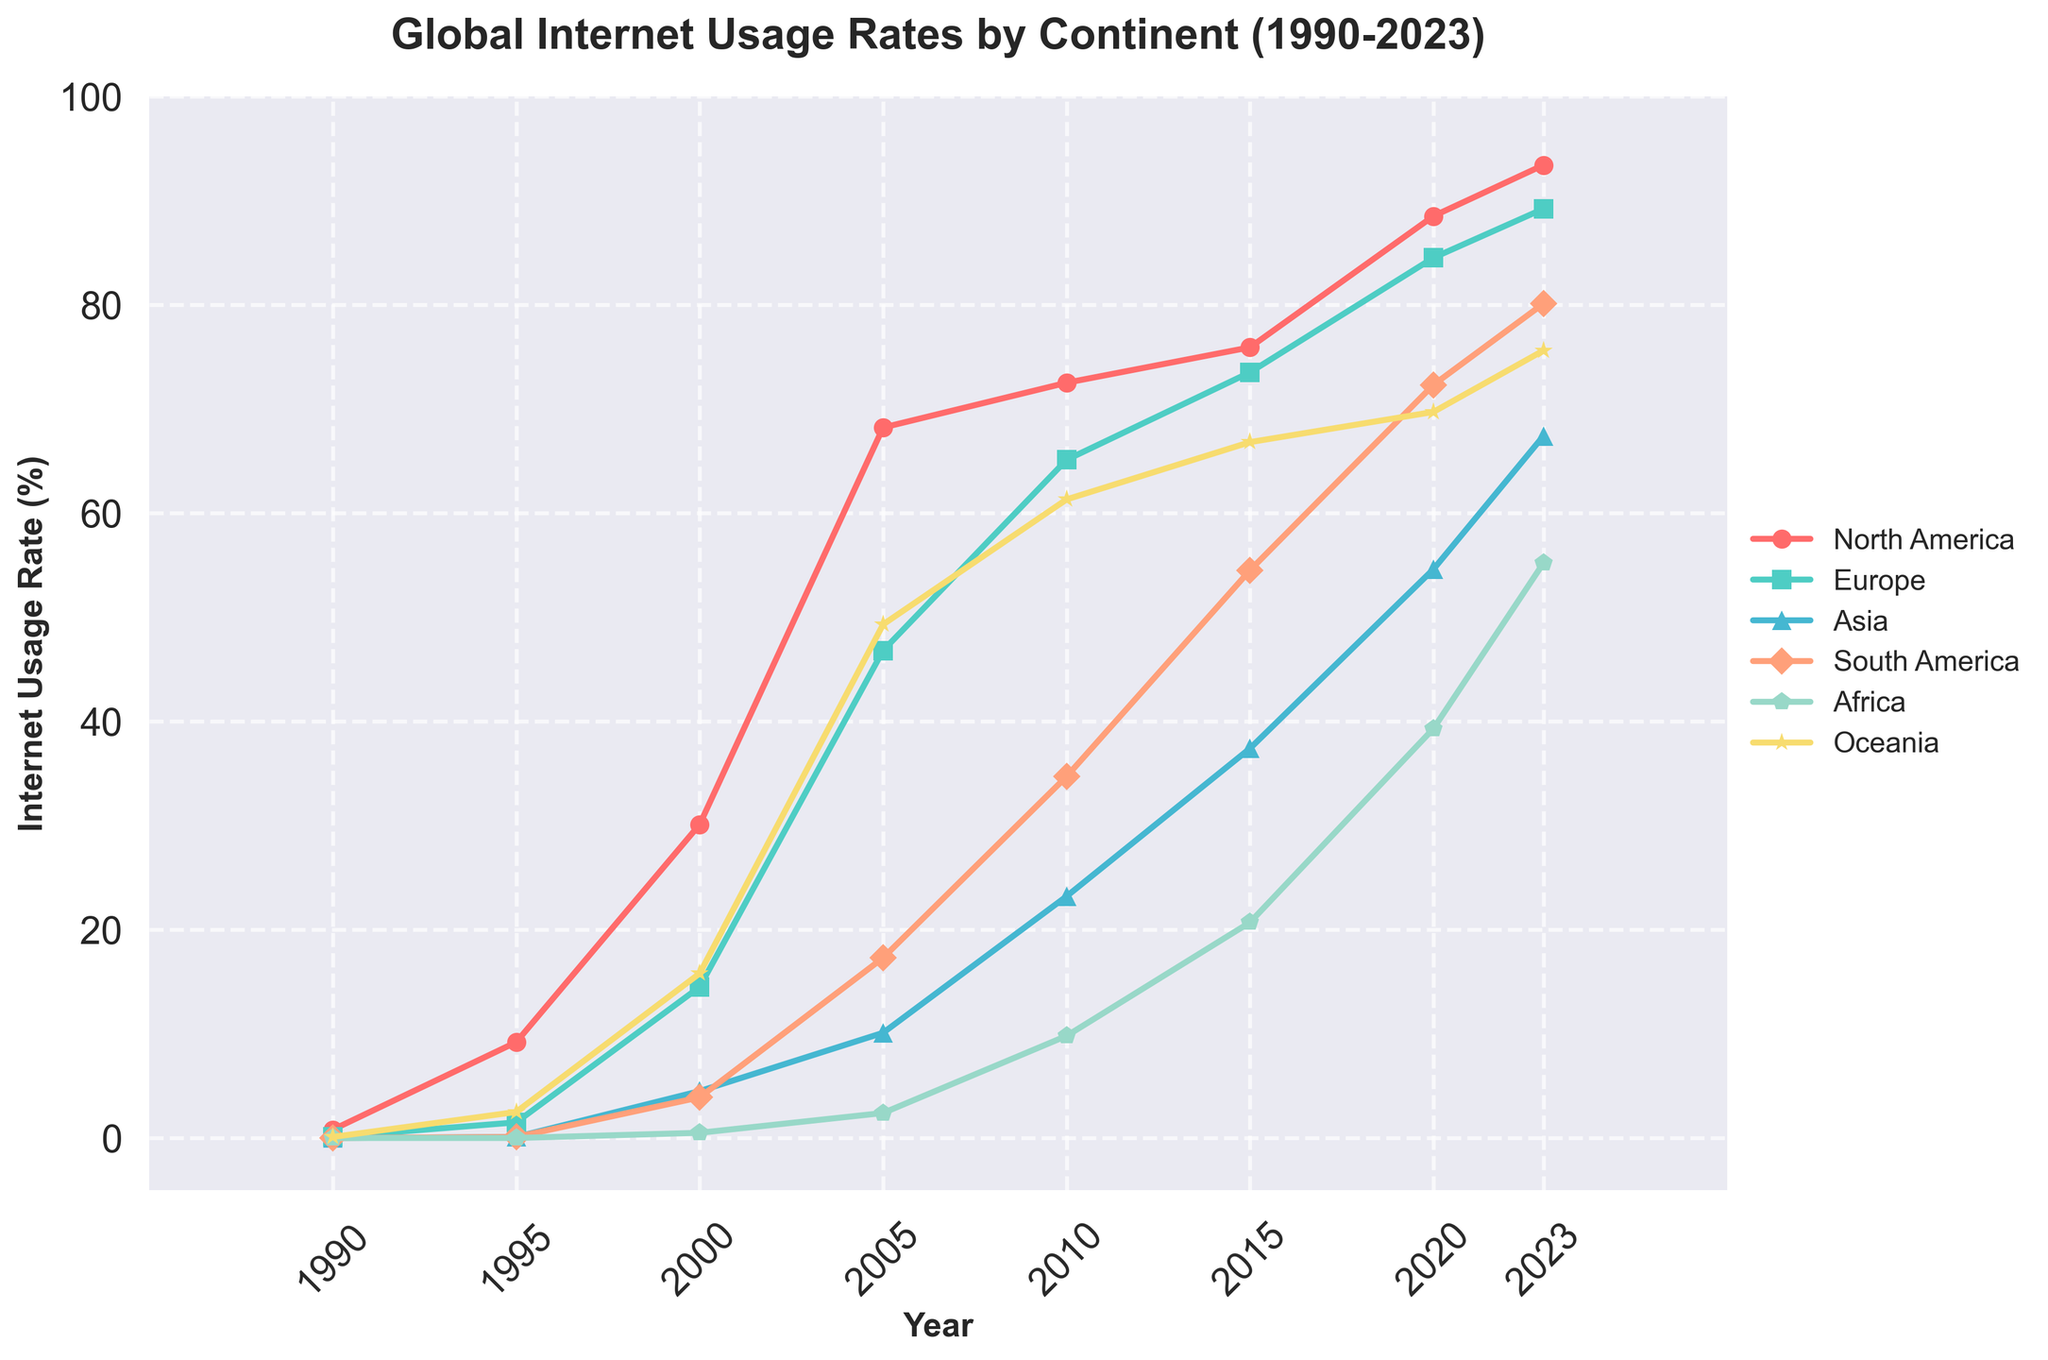What's the internet usage rate in Europe in the year 2000? Find the year 2000 on the x-axis, then look at the data point for Europe. The corresponding y-value indicates the internet usage rate.
Answer: 14.5% How does the internet usage rate in Africa in 2023 compare to 2010? Locate the data points for Africa in the years 2010 and 2023. Compare the y-values. The 2023 point is higher than the 2010 point.
Answer: Higher What is the average internet usage rate in Asia between 1995 and 2005? Sum the internet usage rates in Asia for 1995, 2000, and 2005, then divide by the number of years (3). The values are 0.1, 4.5, and 10.1. (0.1 + 4.5 + 10.1) / 3 = 4.9
Answer: 4.9% Which continent experienced the most significant growth in internet usage between 1990 and 2023? Compare the growth for each continent from 1990 to 2023 by calculating the difference. North America: 93.4 - 0.8 = 92.6, Europe: 89.2 - 0.1 = 89.1, Asia: 67.4 - 0.0 = 67.4, South America: 80.1 - 0.0 = 80.1, Africa: 55.2 - 0.0 = 55.2, Oceania: 75.6 - 0.1 = 75.5. North America has the largest difference.
Answer: North America What color represents South America in the chart? Identify the line associated with South America on the legend and match it to its color.
Answer: Light coral (peach-like color) By how much did the internet usage rate increase in Oceania from 1995 to 2020? Find the internet usage rates for Oceania in 1995 (2.5) and 2020 (69.7). Subtract the 1995 value from the 2020 value: 69.7 - 2.5 = 67.2.
Answer: 67.2% Which continent had the lowest internet usage rate in 2015? Find the data points for all continents in 2015, then compare their values to find the lowest one. Africa had a value of 20.7, which is the lowest.
Answer: Africa What decade saw the highest growth rate in Europe’s internet usage? Calculate the increase in Europe’s internet usage for each decade: 1990-2000: 14.5-0.1=14.4, 2000-2010: 65.1-14.5=50.6, 2010-2020: 84.5-65.1=19.4. The decade 2000-2010 saw the highest growth of 50.6%.
Answer: 2000-2010 